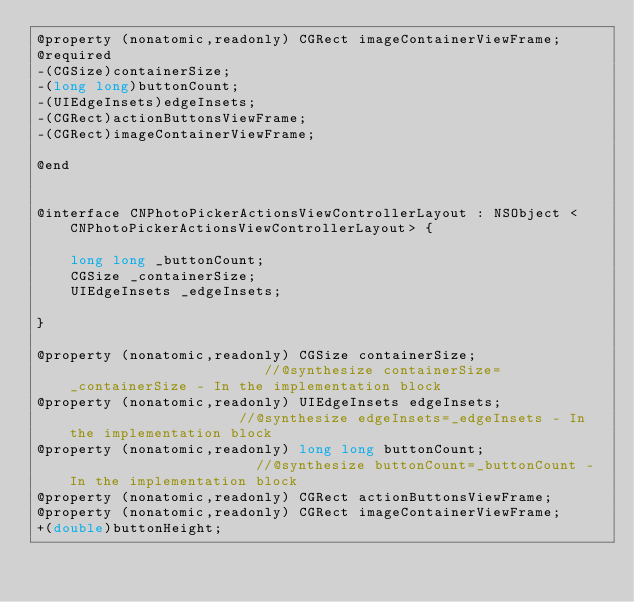Convert code to text. <code><loc_0><loc_0><loc_500><loc_500><_C_>@property (nonatomic,readonly) CGRect imageContainerViewFrame; 
@required
-(CGSize)containerSize;
-(long long)buttonCount;
-(UIEdgeInsets)edgeInsets;
-(CGRect)actionButtonsViewFrame;
-(CGRect)imageContainerViewFrame;

@end


@interface CNPhotoPickerActionsViewControllerLayout : NSObject <CNPhotoPickerActionsViewControllerLayout> {

	long long _buttonCount;
	CGSize _containerSize;
	UIEdgeInsets _edgeInsets;

}

@property (nonatomic,readonly) CGSize containerSize;                        //@synthesize containerSize=_containerSize - In the implementation block
@property (nonatomic,readonly) UIEdgeInsets edgeInsets;                     //@synthesize edgeInsets=_edgeInsets - In the implementation block
@property (nonatomic,readonly) long long buttonCount;                       //@synthesize buttonCount=_buttonCount - In the implementation block
@property (nonatomic,readonly) CGRect actionButtonsViewFrame; 
@property (nonatomic,readonly) CGRect imageContainerViewFrame; 
+(double)buttonHeight;</code> 